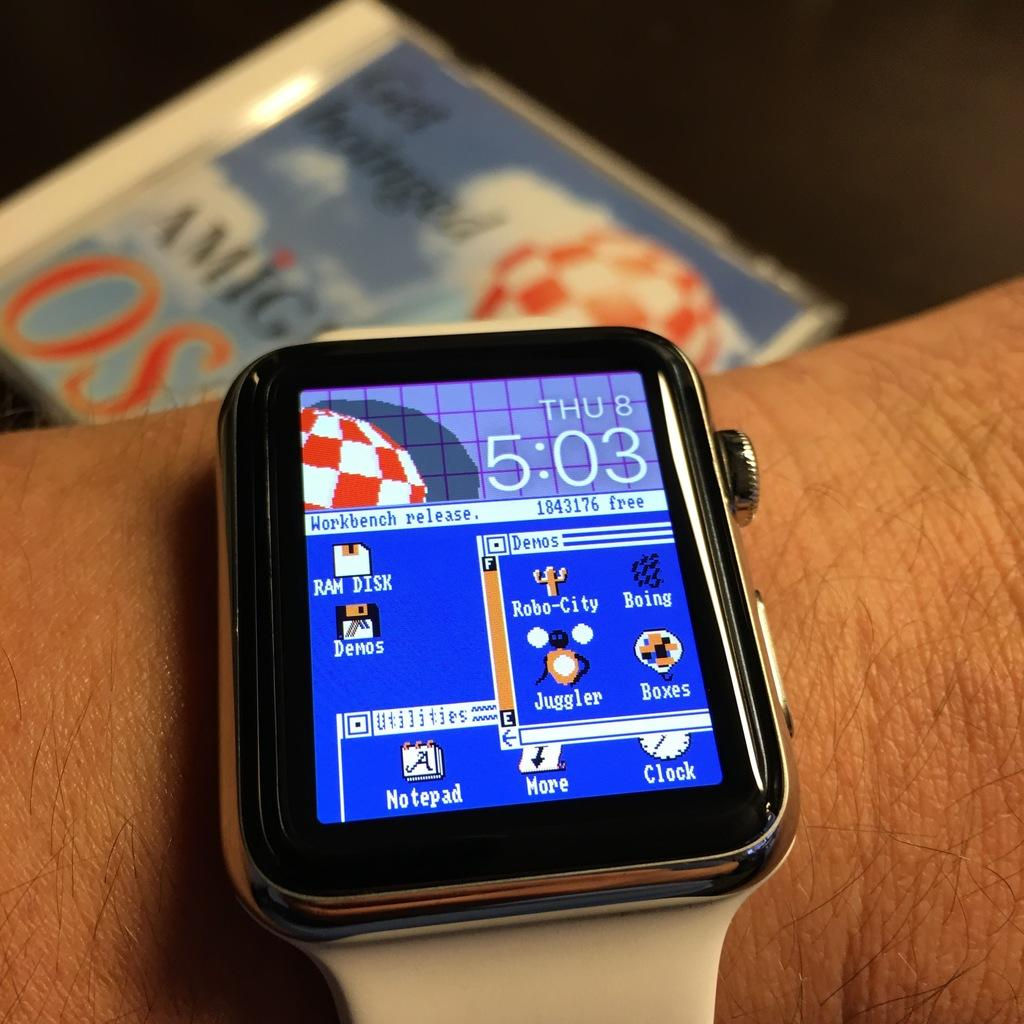<image>
Present a compact description of the photo's key features. wrist with a smartwatch on it showing it is thursday the 8th at 5:03 